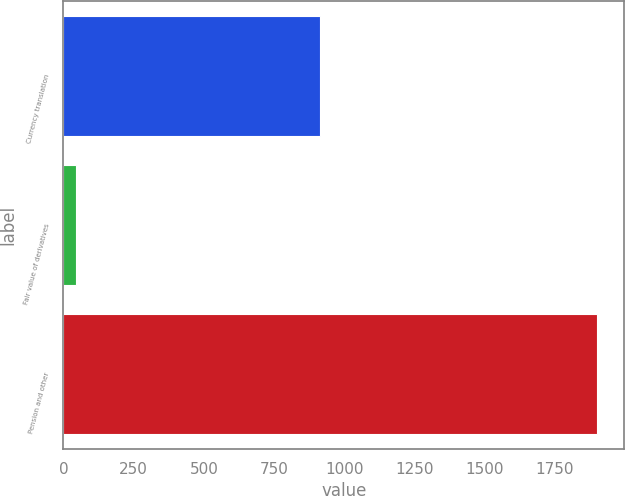<chart> <loc_0><loc_0><loc_500><loc_500><bar_chart><fcel>Currency translation<fcel>Fair value of derivatives<fcel>Pension and other<nl><fcel>912<fcel>45<fcel>1901<nl></chart> 